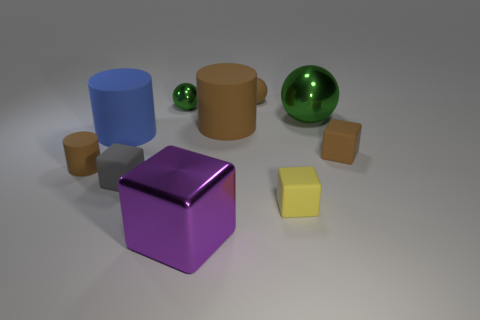The large shiny object that is on the right side of the large cube is what color? The large shiny object to the right of the prominent cube in the image is a vibrant shade of green, reminiscent of emerald or jade. 